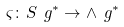<formula> <loc_0><loc_0><loc_500><loc_500>\varsigma \colon S \ g ^ { * } \to \wedge \ g ^ { * }</formula> 